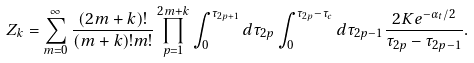Convert formula to latex. <formula><loc_0><loc_0><loc_500><loc_500>Z _ { k } = \sum _ { m = 0 } ^ { \infty } \frac { ( 2 m + k ) ! } { ( m + k ) ! m ! } \prod _ { p = 1 } ^ { 2 m + k } \int _ { 0 } ^ { \tau _ { 2 p + 1 } } d \tau _ { 2 p } \int _ { 0 } ^ { \tau _ { 2 p } - \tau _ { c } } d \tau _ { 2 p - 1 } \frac { 2 K e ^ { - \alpha _ { t } / 2 } } { \tau _ { 2 p } - \tau _ { 2 p - 1 } } .</formula> 